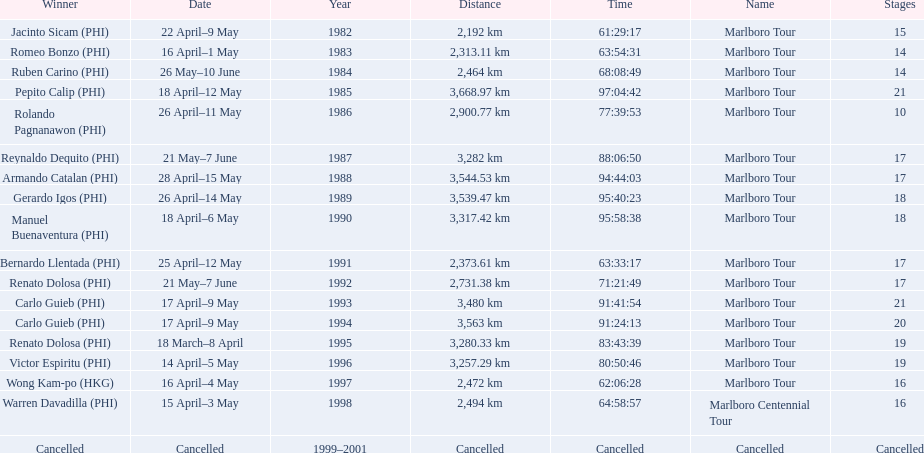Which year did warren davdilla (w.d.) appear? 1998. What tour did w.d. complete? Marlboro Centennial Tour. What is the time recorded in the same row as w.d.? 64:58:57. 